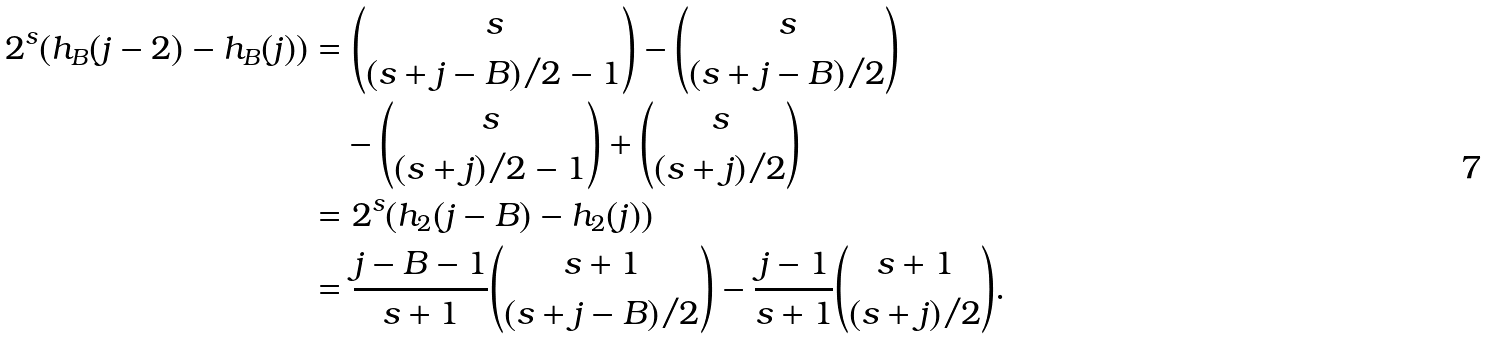Convert formula to latex. <formula><loc_0><loc_0><loc_500><loc_500>2 ^ { s } ( h _ { B } ( j - 2 ) - h _ { B } ( j ) ) & = \binom { s } { ( s + j - B ) / 2 - 1 } - \binom { s } { ( s + j - B ) / 2 } \\ & \quad - \binom { s } { ( s + j ) / 2 - 1 } + \binom { s } { ( s + j ) / 2 } \\ & = 2 ^ { s } ( h _ { 2 } ( j - B ) - h _ { 2 } ( j ) ) \\ & = \frac { j - B - 1 } { s + 1 } \binom { s + 1 } { ( s + j - B ) / 2 } - \frac { j - 1 } { s + 1 } \binom { s + 1 } { ( s + j ) / 2 } .</formula> 